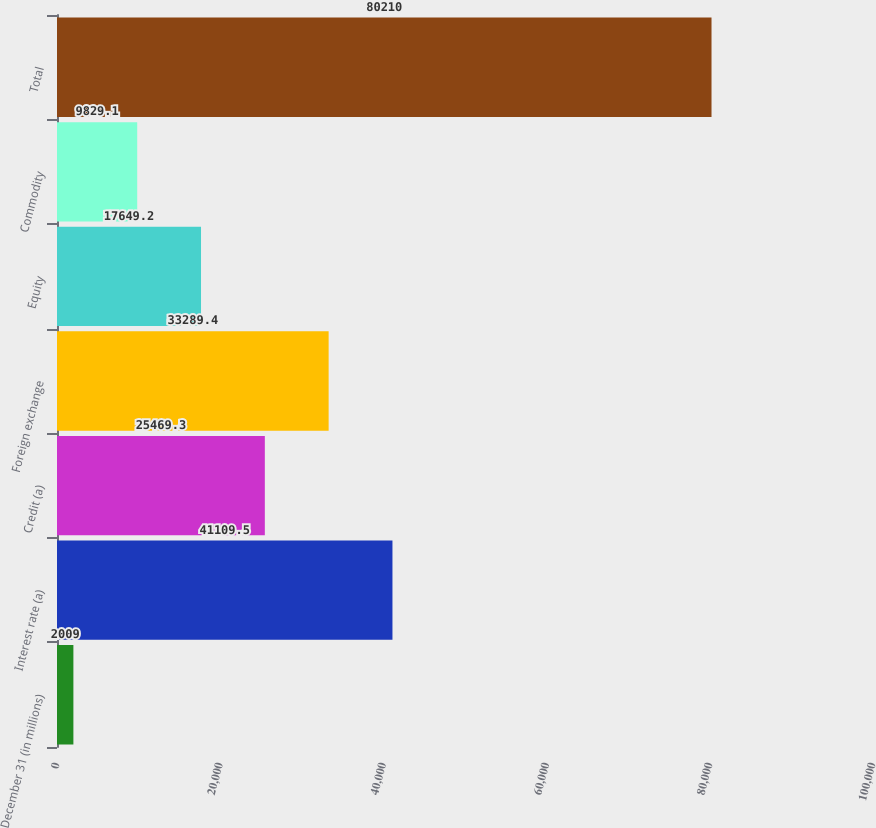Convert chart to OTSL. <chart><loc_0><loc_0><loc_500><loc_500><bar_chart><fcel>December 31 (in millions)<fcel>Interest rate (a)<fcel>Credit (a)<fcel>Foreign exchange<fcel>Equity<fcel>Commodity<fcel>Total<nl><fcel>2009<fcel>41109.5<fcel>25469.3<fcel>33289.4<fcel>17649.2<fcel>9829.1<fcel>80210<nl></chart> 